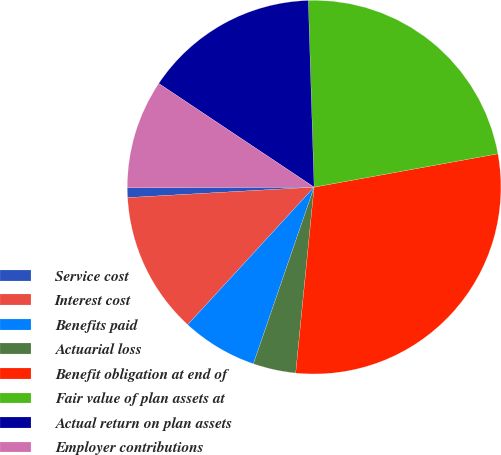Convert chart. <chart><loc_0><loc_0><loc_500><loc_500><pie_chart><fcel>Service cost<fcel>Interest cost<fcel>Benefits paid<fcel>Actuarial loss<fcel>Benefit obligation at end of<fcel>Fair value of plan assets at<fcel>Actual return on plan assets<fcel>Employer contributions<nl><fcel>0.84%<fcel>12.28%<fcel>6.56%<fcel>3.7%<fcel>29.43%<fcel>22.64%<fcel>15.14%<fcel>9.42%<nl></chart> 